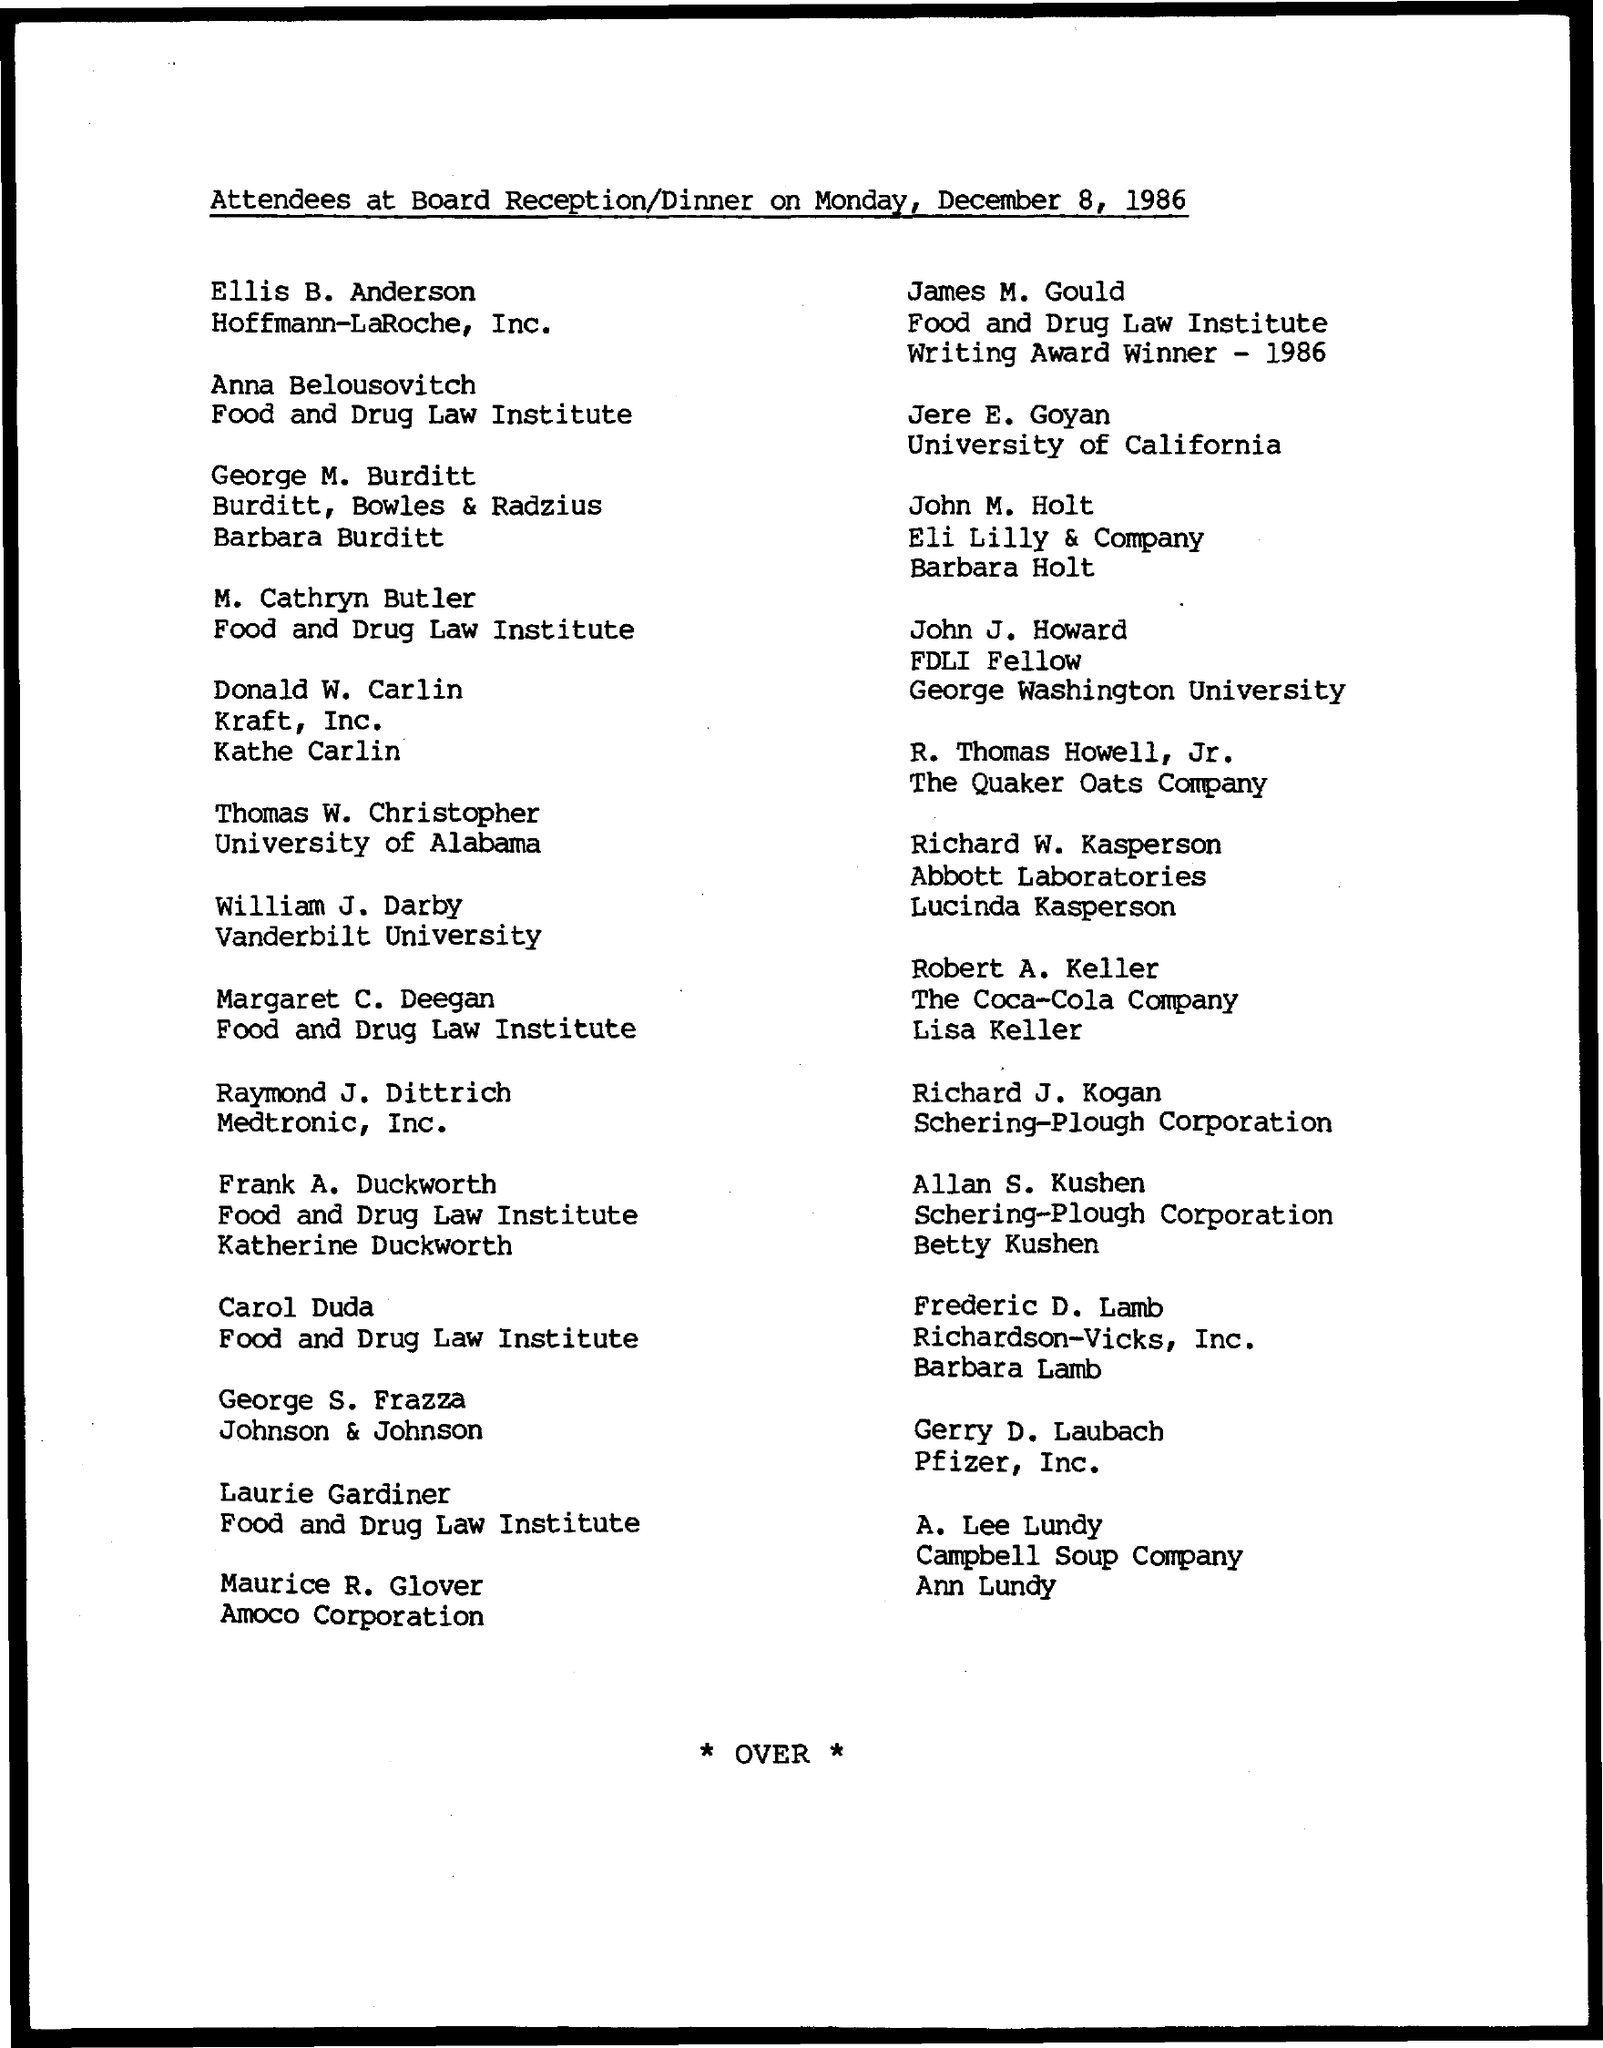Mention a couple of crucial points in this snapshot. Jere E. Goyan is from the University of California. On Monday, December 8, 1986, the Board Receipt/Dinner was held. 